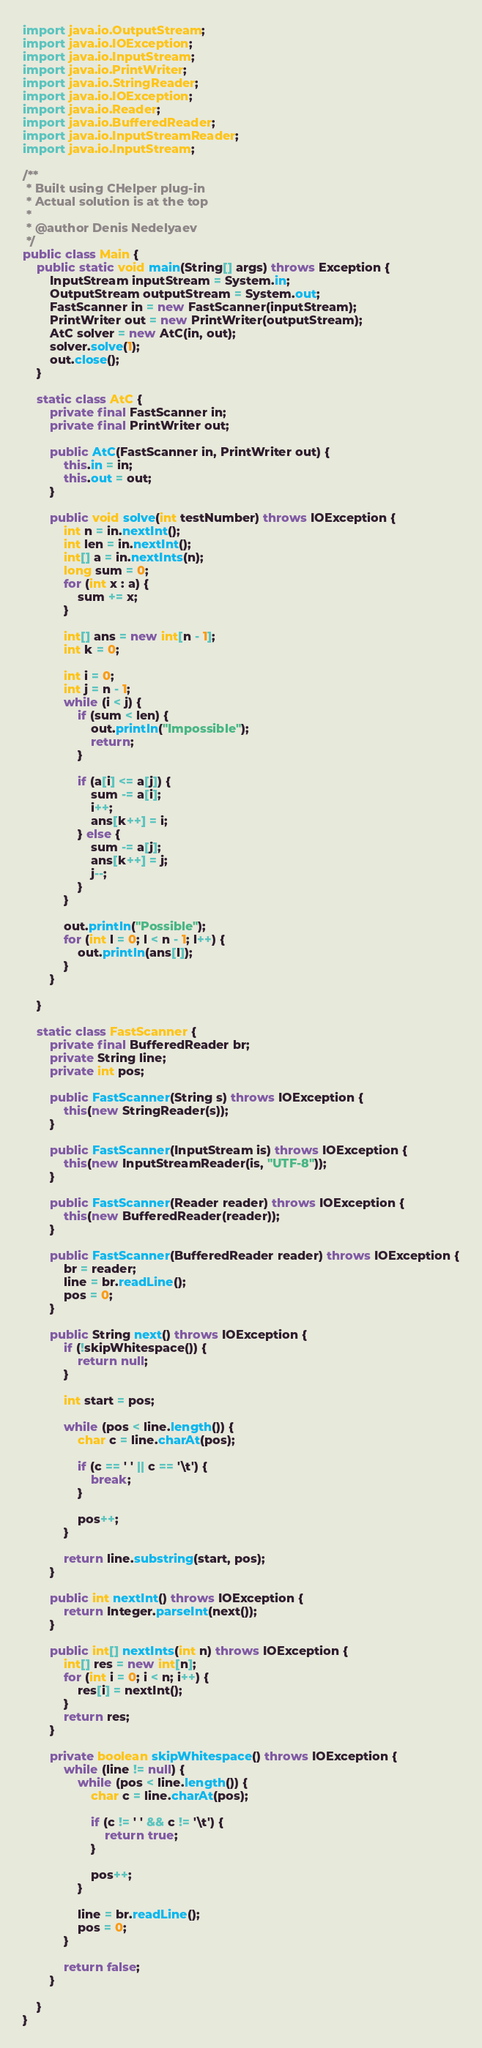Convert code to text. <code><loc_0><loc_0><loc_500><loc_500><_Java_>import java.io.OutputStream;
import java.io.IOException;
import java.io.InputStream;
import java.io.PrintWriter;
import java.io.StringReader;
import java.io.IOException;
import java.io.Reader;
import java.io.BufferedReader;
import java.io.InputStreamReader;
import java.io.InputStream;

/**
 * Built using CHelper plug-in
 * Actual solution is at the top
 *
 * @author Denis Nedelyaev
 */
public class Main {
    public static void main(String[] args) throws Exception {
        InputStream inputStream = System.in;
        OutputStream outputStream = System.out;
        FastScanner in = new FastScanner(inputStream);
        PrintWriter out = new PrintWriter(outputStream);
        AtC solver = new AtC(in, out);
        solver.solve(1);
        out.close();
    }

    static class AtC {
        private final FastScanner in;
        private final PrintWriter out;

        public AtC(FastScanner in, PrintWriter out) {
            this.in = in;
            this.out = out;
        }

        public void solve(int testNumber) throws IOException {
            int n = in.nextInt();
            int len = in.nextInt();
            int[] a = in.nextInts(n);
            long sum = 0;
            for (int x : a) {
                sum += x;
            }

            int[] ans = new int[n - 1];
            int k = 0;

            int i = 0;
            int j = n - 1;
            while (i < j) {
                if (sum < len) {
                    out.println("Impossible");
                    return;
                }

                if (a[i] <= a[j]) {
                    sum -= a[i];
                    i++;
                    ans[k++] = i;
                } else {
                    sum -= a[j];
                    ans[k++] = j;
                    j--;
                }
            }

            out.println("Possible");
            for (int l = 0; l < n - 1; l++) {
                out.println(ans[l]);
            }
        }

    }

    static class FastScanner {
        private final BufferedReader br;
        private String line;
        private int pos;

        public FastScanner(String s) throws IOException {
            this(new StringReader(s));
        }

        public FastScanner(InputStream is) throws IOException {
            this(new InputStreamReader(is, "UTF-8"));
        }

        public FastScanner(Reader reader) throws IOException {
            this(new BufferedReader(reader));
        }

        public FastScanner(BufferedReader reader) throws IOException {
            br = reader;
            line = br.readLine();
            pos = 0;
        }

        public String next() throws IOException {
            if (!skipWhitespace()) {
                return null;
            }

            int start = pos;

            while (pos < line.length()) {
                char c = line.charAt(pos);

                if (c == ' ' || c == '\t') {
                    break;
                }

                pos++;
            }

            return line.substring(start, pos);
        }

        public int nextInt() throws IOException {
            return Integer.parseInt(next());
        }

        public int[] nextInts(int n) throws IOException {
            int[] res = new int[n];
            for (int i = 0; i < n; i++) {
                res[i] = nextInt();
            }
            return res;
        }

        private boolean skipWhitespace() throws IOException {
            while (line != null) {
                while (pos < line.length()) {
                    char c = line.charAt(pos);

                    if (c != ' ' && c != '\t') {
                        return true;
                    }

                    pos++;
                }

                line = br.readLine();
                pos = 0;
            }

            return false;
        }

    }
}

</code> 